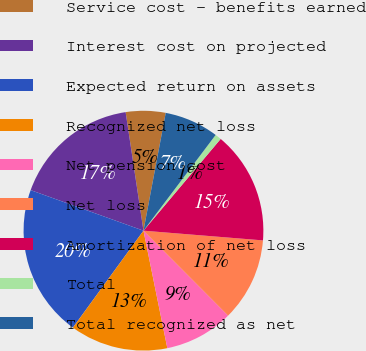<chart> <loc_0><loc_0><loc_500><loc_500><pie_chart><fcel>Service cost - benefits earned<fcel>Interest cost on projected<fcel>Expected return on assets<fcel>Recognized net loss<fcel>Net pension cost<fcel>Net loss<fcel>Amortization of net loss<fcel>Total<fcel>Total recognized as net<nl><fcel>5.35%<fcel>17.13%<fcel>20.48%<fcel>13.2%<fcel>9.28%<fcel>11.24%<fcel>15.16%<fcel>0.85%<fcel>7.31%<nl></chart> 